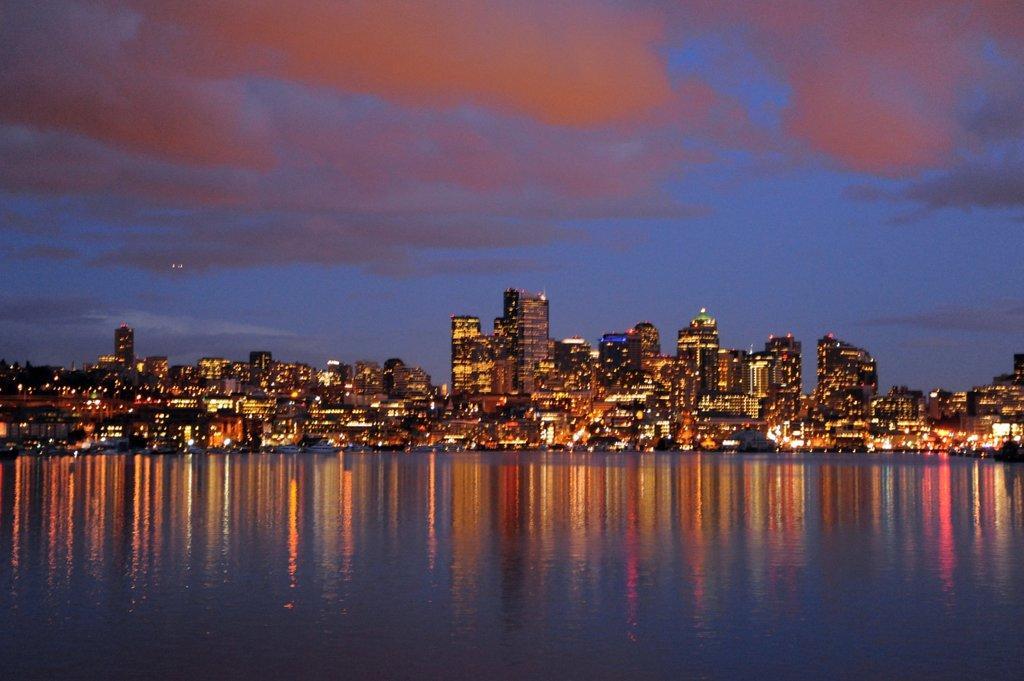Could you give a brief overview of what you see in this image? In this picture we can see water, beside the water we can see buildings with lights and we can see sky in the background. 